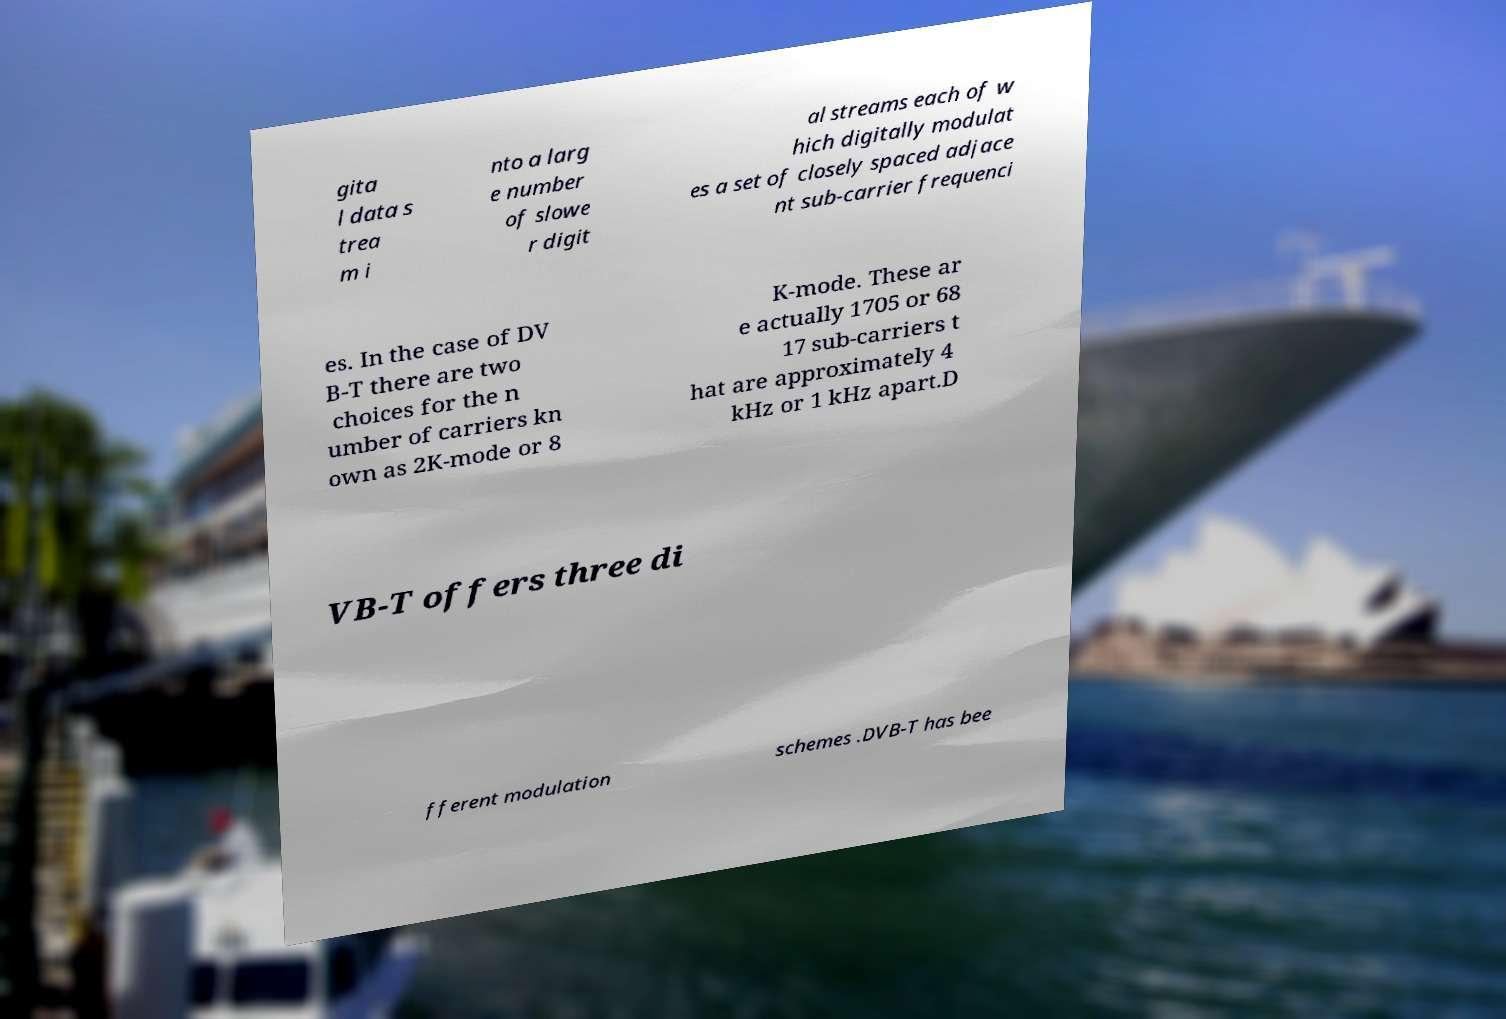Please identify and transcribe the text found in this image. gita l data s trea m i nto a larg e number of slowe r digit al streams each of w hich digitally modulat es a set of closely spaced adjace nt sub-carrier frequenci es. In the case of DV B-T there are two choices for the n umber of carriers kn own as 2K-mode or 8 K-mode. These ar e actually 1705 or 68 17 sub-carriers t hat are approximately 4 kHz or 1 kHz apart.D VB-T offers three di fferent modulation schemes .DVB-T has bee 